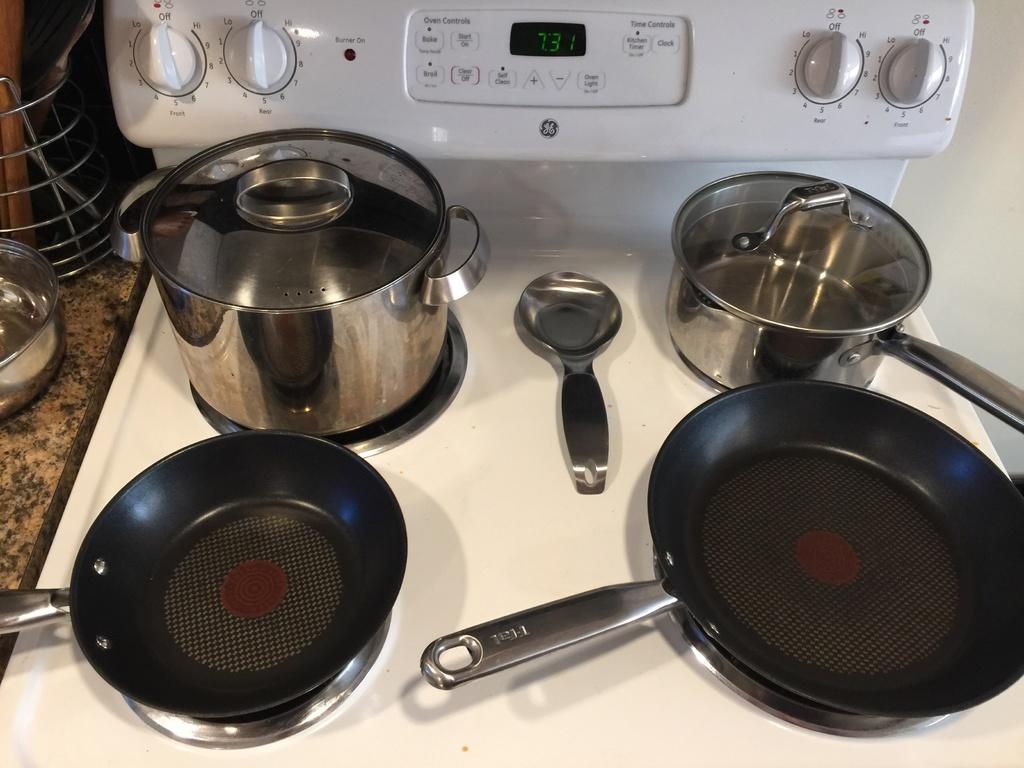Provide a one-sentence caption for the provided image. pots and pans on a GE stove top with digital clock at 7:31. 